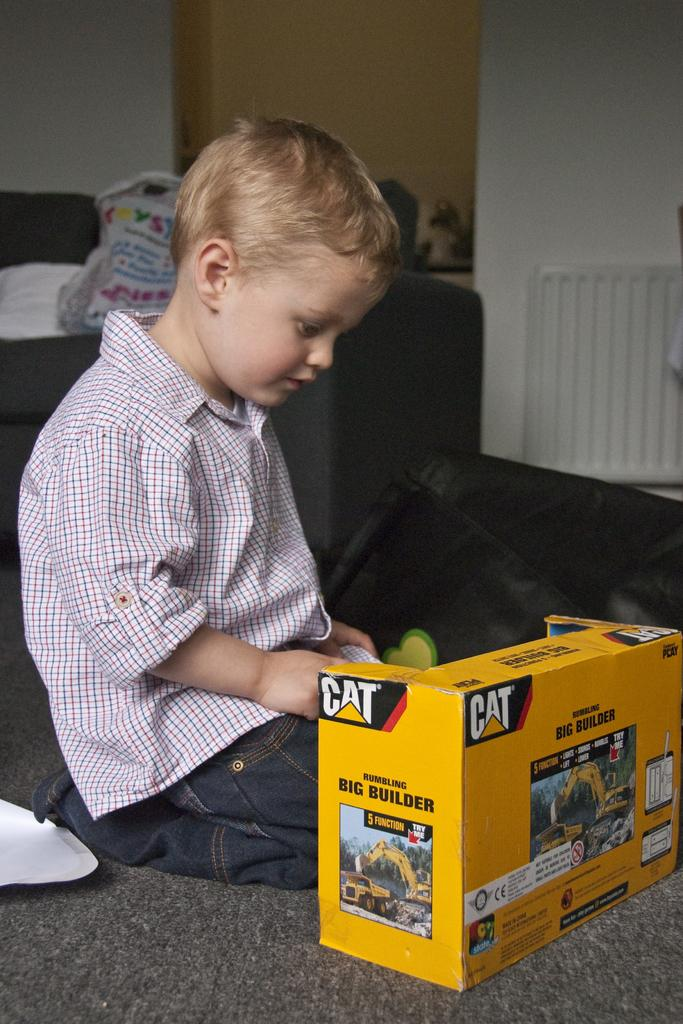<image>
Summarize the visual content of the image. A young boy plays with a Cat brand truck toy. 